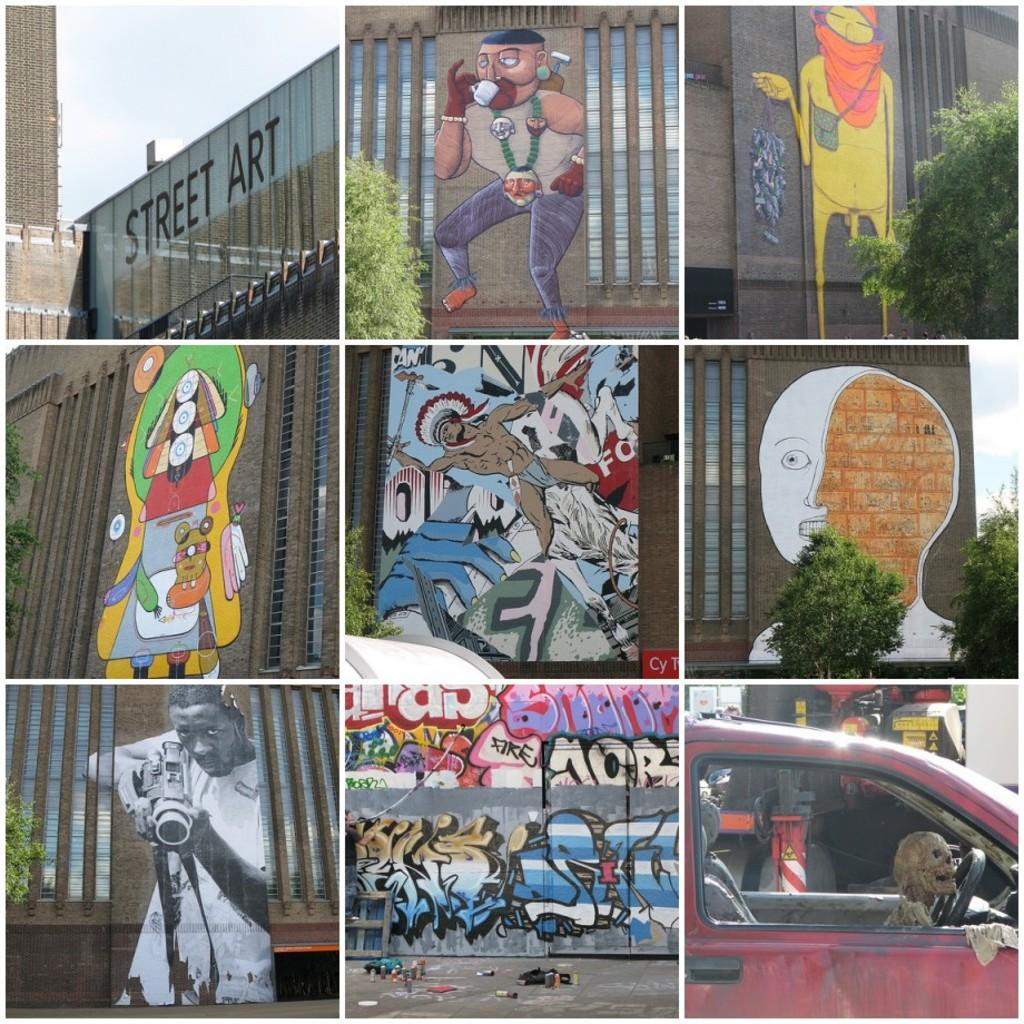What can be seen on the wall in the foreground of the image? There are paintings on the wall in the foreground of the image. What type of natural elements are visible in the image? There are trees visible in the image. What is written on a building in the image? There is a name on a building in the image. What unusual scene can be observed in the image? There is a skeleton in a car in the image. What type of wool can be seen on the lizards in the image? There are no lizards or wool present in the image. What health advice is given on the building in the image? There is no health advice present on the building in the image; it only has a name. 